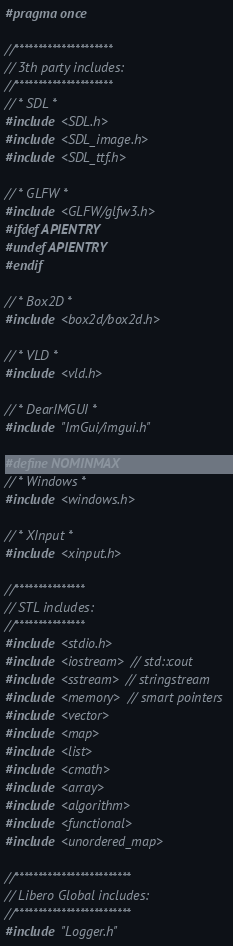Convert code to text. <code><loc_0><loc_0><loc_500><loc_500><_C_>#pragma once

//*********************
// 3th party includes:
//*********************
// * SDL *
#include <SDL.h>
#include <SDL_image.h>
#include <SDL_ttf.h>

// * GLFW *
#include <GLFW/glfw3.h>
#ifdef APIENTRY
#undef APIENTRY
#endif

// * Box2D *
#include <box2d/box2d.h>

// * VLD *
#include <vld.h>

// * DearIMGUI *
#include "ImGui/imgui.h"

#define NOMINMAX
// * Windows *
#include <windows.h>

// * XInput *
#include <xinput.h>

//***************
// STL includes:
//***************
#include <stdio.h>
#include <iostream> // std::cout
#include <sstream> // stringstream
#include <memory> // smart pointers
#include <vector>
#include <map>
#include <list>
#include <cmath>
#include <array>
#include <algorithm>
#include <functional>
#include <unordered_map>

//*************************
// Libero Global includes:
//*************************
#include "Logger.h"
</code> 